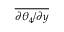<formula> <loc_0><loc_0><loc_500><loc_500>\overline { { { \partial \theta _ { 4 } } / { \partial y } } }</formula> 